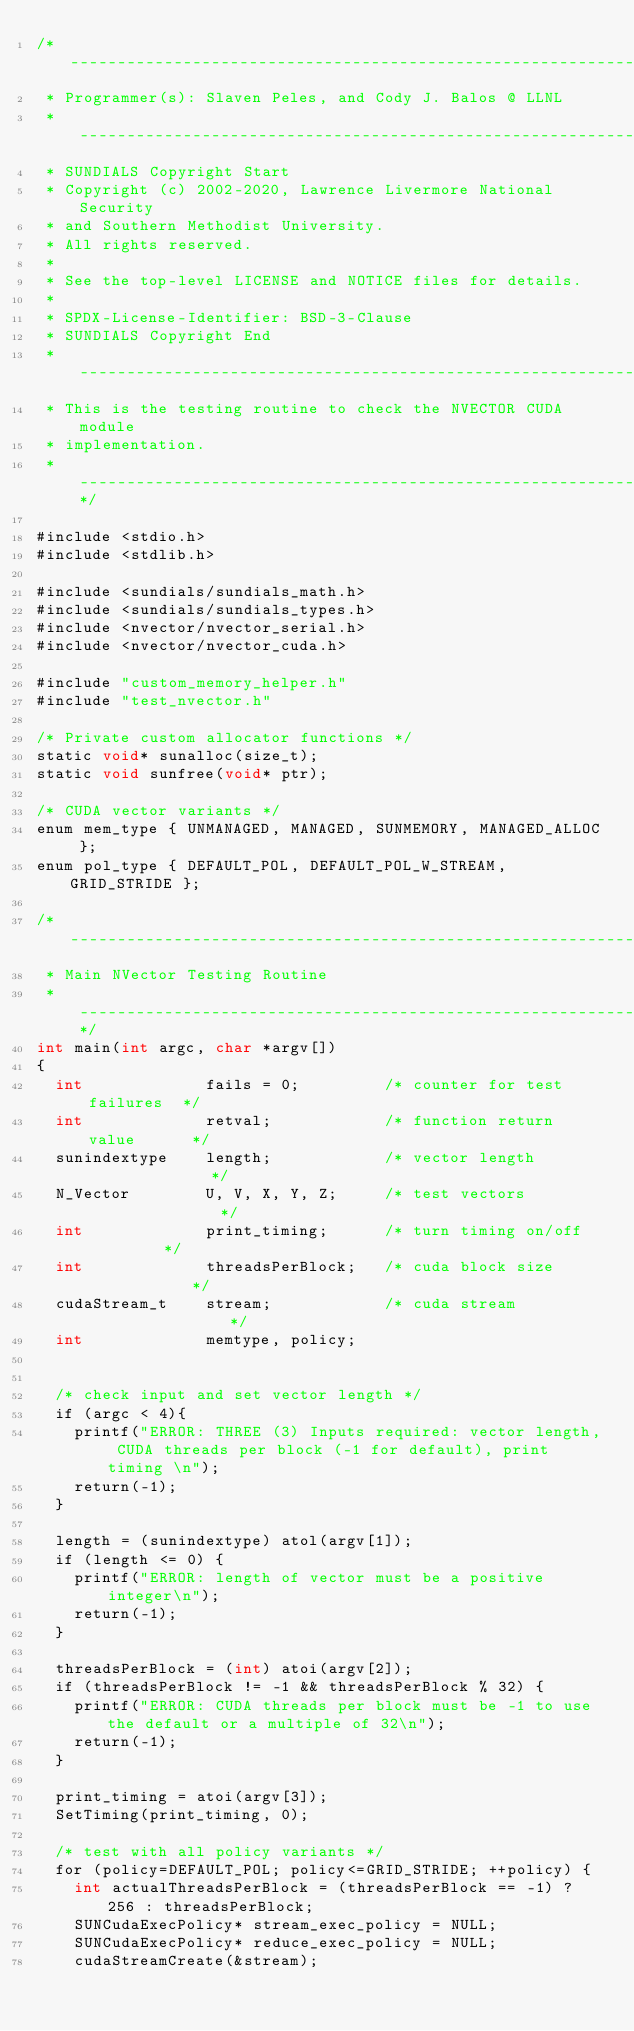Convert code to text. <code><loc_0><loc_0><loc_500><loc_500><_Cuda_>/* -----------------------------------------------------------------
 * Programmer(s): Slaven Peles, and Cody J. Balos @ LLNL
 * -----------------------------------------------------------------
 * SUNDIALS Copyright Start
 * Copyright (c) 2002-2020, Lawrence Livermore National Security
 * and Southern Methodist University.
 * All rights reserved.
 *
 * See the top-level LICENSE and NOTICE files for details.
 *
 * SPDX-License-Identifier: BSD-3-Clause
 * SUNDIALS Copyright End
 * -----------------------------------------------------------------
 * This is the testing routine to check the NVECTOR CUDA module
 * implementation.
 * -----------------------------------------------------------------*/

#include <stdio.h>
#include <stdlib.h>

#include <sundials/sundials_math.h>
#include <sundials/sundials_types.h>
#include <nvector/nvector_serial.h>
#include <nvector/nvector_cuda.h>

#include "custom_memory_helper.h"
#include "test_nvector.h"

/* Private custom allocator functions */
static void* sunalloc(size_t);
static void sunfree(void* ptr);

/* CUDA vector variants */
enum mem_type { UNMANAGED, MANAGED, SUNMEMORY, MANAGED_ALLOC };
enum pol_type { DEFAULT_POL, DEFAULT_POL_W_STREAM, GRID_STRIDE };

/* ----------------------------------------------------------------------
 * Main NVector Testing Routine
 * --------------------------------------------------------------------*/
int main(int argc, char *argv[])
{
  int             fails = 0;         /* counter for test failures  */
  int             retval;            /* function return value      */
  sunindextype    length;            /* vector length              */
  N_Vector        U, V, X, Y, Z;     /* test vectors               */
  int             print_timing;      /* turn timing on/off         */
  int             threadsPerBlock;   /* cuda block size            */
  cudaStream_t    stream;            /* cuda stream                */
  int             memtype, policy;


  /* check input and set vector length */
  if (argc < 4){
    printf("ERROR: THREE (3) Inputs required: vector length, CUDA threads per block (-1 for default), print timing \n");
    return(-1);
  }

  length = (sunindextype) atol(argv[1]);
  if (length <= 0) {
    printf("ERROR: length of vector must be a positive integer\n");
    return(-1);
  }

  threadsPerBlock = (int) atoi(argv[2]);
  if (threadsPerBlock != -1 && threadsPerBlock % 32) {
    printf("ERROR: CUDA threads per block must be -1 to use the default or a multiple of 32\n");
    return(-1);
  }

  print_timing = atoi(argv[3]);
  SetTiming(print_timing, 0);

  /* test with all policy variants */
  for (policy=DEFAULT_POL; policy<=GRID_STRIDE; ++policy) {
    int actualThreadsPerBlock = (threadsPerBlock == -1) ? 256 : threadsPerBlock;
    SUNCudaExecPolicy* stream_exec_policy = NULL;
    SUNCudaExecPolicy* reduce_exec_policy = NULL;
    cudaStreamCreate(&stream);
</code> 